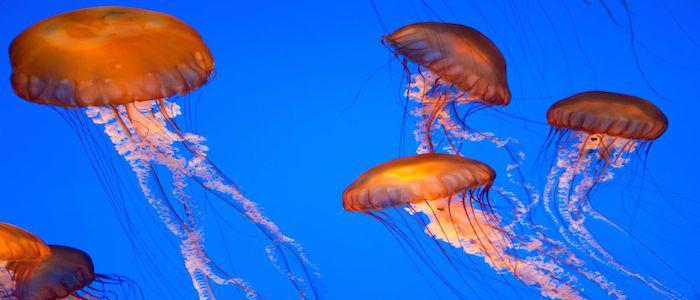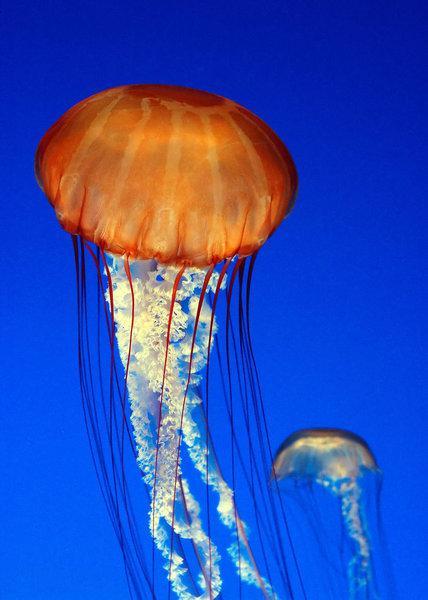The first image is the image on the left, the second image is the image on the right. Considering the images on both sides, is "Several jellyfish are swimming in the water in the image on the left." valid? Answer yes or no. Yes. The first image is the image on the left, the second image is the image on the right. Assess this claim about the two images: "An image contains one prominet jellyfish, which has reddish orange """"cap"""" and string-like red tendrils trailing downward.". Correct or not? Answer yes or no. Yes. 